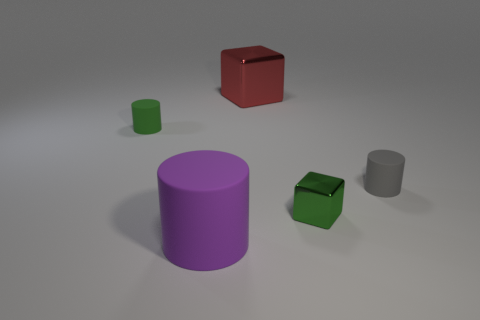Are there any green metallic cubes behind the tiny green matte cylinder?
Ensure brevity in your answer.  No. Is there a green thing that has the same shape as the big purple rubber thing?
Ensure brevity in your answer.  Yes. Is the shape of the big thing behind the small metal thing the same as the green object that is on the right side of the big purple thing?
Provide a succinct answer. Yes. Is there a green rubber object of the same size as the green metallic cube?
Make the answer very short. Yes. Are there the same number of tiny green objects that are to the right of the green rubber cylinder and small metallic cubes that are in front of the green metal block?
Ensure brevity in your answer.  No. Is the thing that is in front of the green metal block made of the same material as the tiny cylinder that is to the left of the big red cube?
Give a very brief answer. Yes. What is the material of the green cylinder?
Give a very brief answer. Rubber. What number of other objects are the same color as the small cube?
Keep it short and to the point. 1. How many big brown balls are there?
Offer a terse response. 0. There is a big thing that is behind the large thing left of the big metallic cube; what is it made of?
Give a very brief answer. Metal. 